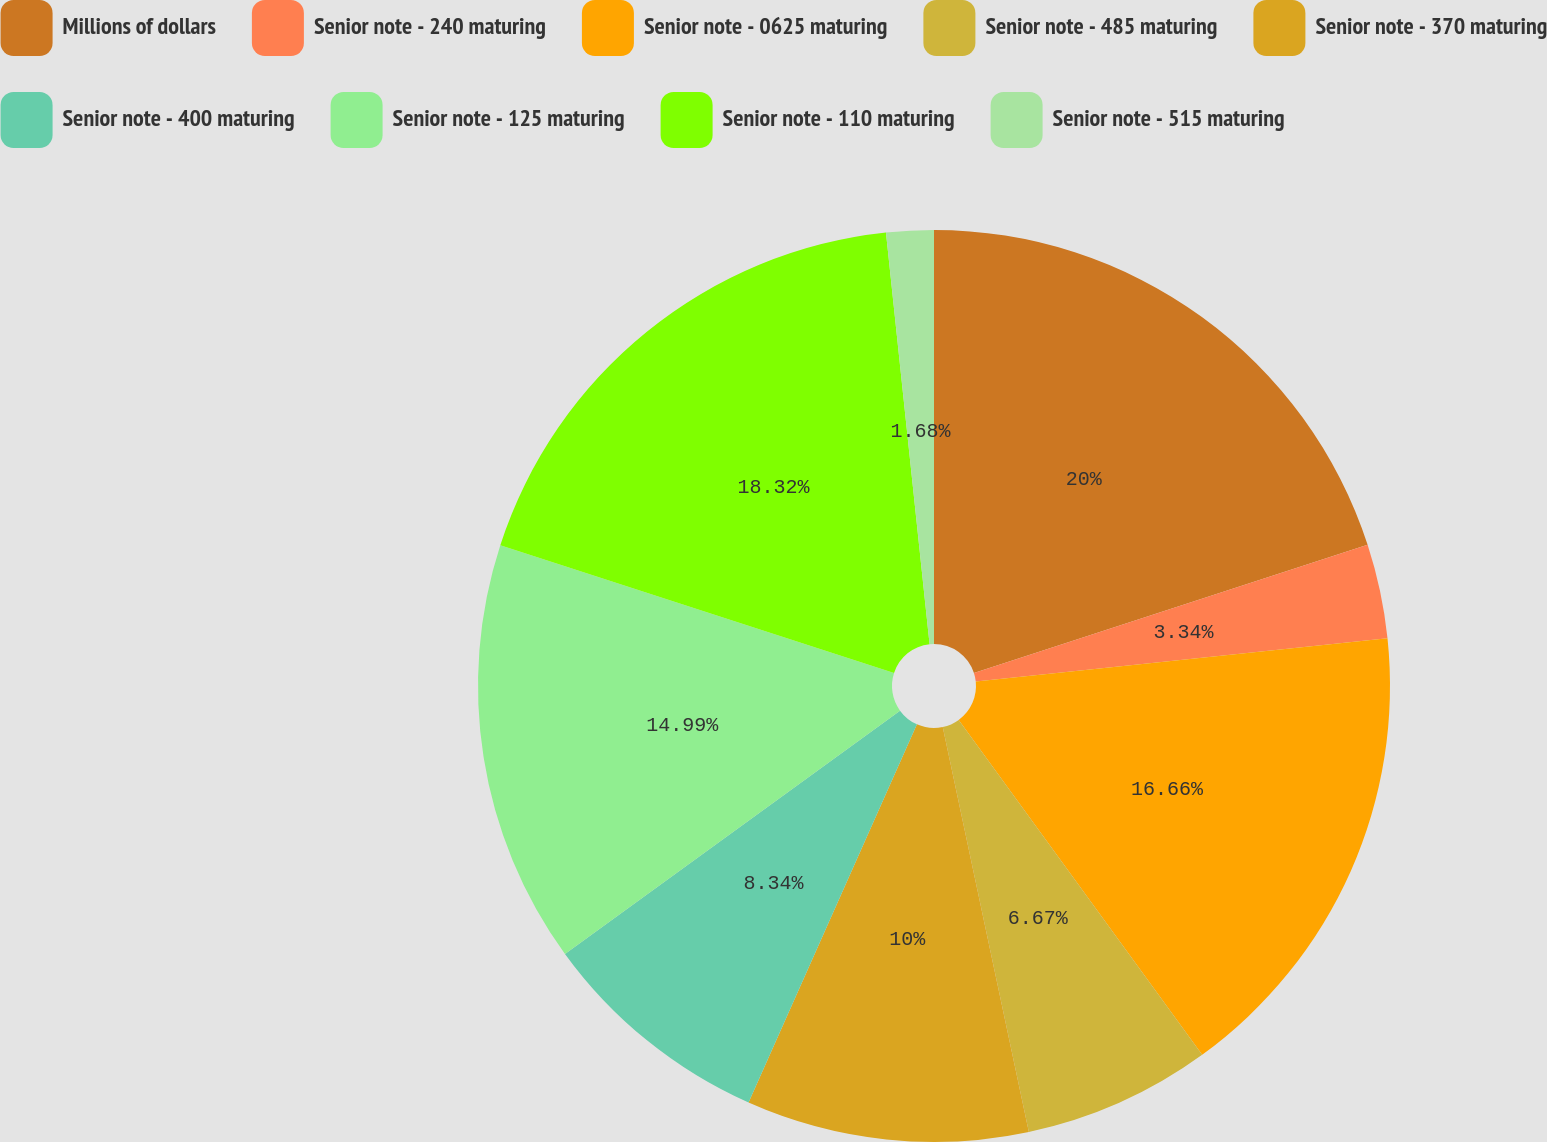<chart> <loc_0><loc_0><loc_500><loc_500><pie_chart><fcel>Millions of dollars<fcel>Senior note - 240 maturing<fcel>Senior note - 0625 maturing<fcel>Senior note - 485 maturing<fcel>Senior note - 370 maturing<fcel>Senior note - 400 maturing<fcel>Senior note - 125 maturing<fcel>Senior note - 110 maturing<fcel>Senior note - 515 maturing<nl><fcel>19.99%<fcel>3.34%<fcel>16.66%<fcel>6.67%<fcel>10.0%<fcel>8.34%<fcel>14.99%<fcel>18.32%<fcel>1.68%<nl></chart> 